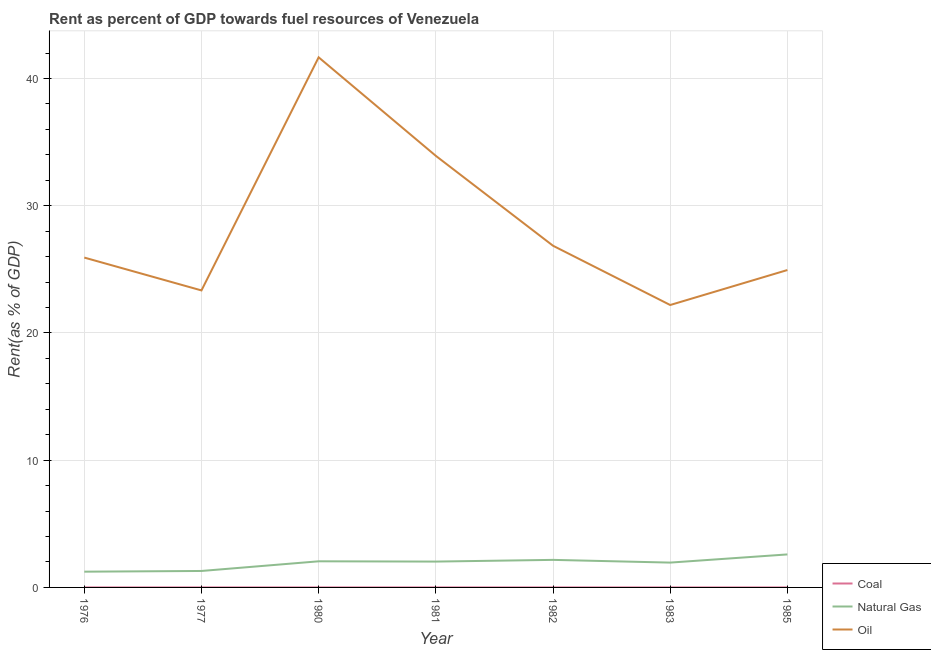Is the number of lines equal to the number of legend labels?
Your answer should be compact. Yes. What is the rent towards natural gas in 1981?
Your answer should be very brief. 2.03. Across all years, what is the maximum rent towards natural gas?
Offer a terse response. 2.59. Across all years, what is the minimum rent towards coal?
Provide a short and direct response. 0. What is the total rent towards natural gas in the graph?
Your answer should be very brief. 13.33. What is the difference between the rent towards oil in 1980 and that in 1982?
Your answer should be very brief. 14.81. What is the difference between the rent towards coal in 1977 and the rent towards natural gas in 1976?
Make the answer very short. -1.24. What is the average rent towards natural gas per year?
Offer a terse response. 1.9. In the year 1981, what is the difference between the rent towards coal and rent towards natural gas?
Offer a terse response. -2.03. What is the ratio of the rent towards oil in 1982 to that in 1985?
Your response must be concise. 1.08. What is the difference between the highest and the second highest rent towards coal?
Provide a short and direct response. 0. What is the difference between the highest and the lowest rent towards coal?
Make the answer very short. 0. Is it the case that in every year, the sum of the rent towards coal and rent towards natural gas is greater than the rent towards oil?
Your answer should be very brief. No. Does the rent towards natural gas monotonically increase over the years?
Offer a very short reply. No. Is the rent towards oil strictly greater than the rent towards natural gas over the years?
Keep it short and to the point. Yes. Is the rent towards coal strictly less than the rent towards oil over the years?
Offer a very short reply. Yes. How many lines are there?
Ensure brevity in your answer.  3. What is the difference between two consecutive major ticks on the Y-axis?
Provide a succinct answer. 10. Where does the legend appear in the graph?
Offer a terse response. Bottom right. How many legend labels are there?
Your response must be concise. 3. How are the legend labels stacked?
Make the answer very short. Vertical. What is the title of the graph?
Offer a terse response. Rent as percent of GDP towards fuel resources of Venezuela. Does "Social insurance" appear as one of the legend labels in the graph?
Offer a terse response. No. What is the label or title of the Y-axis?
Your answer should be very brief. Rent(as % of GDP). What is the Rent(as % of GDP) in Coal in 1976?
Ensure brevity in your answer.  0. What is the Rent(as % of GDP) of Natural Gas in 1976?
Make the answer very short. 1.24. What is the Rent(as % of GDP) of Oil in 1976?
Give a very brief answer. 25.92. What is the Rent(as % of GDP) of Coal in 1977?
Offer a very short reply. 0. What is the Rent(as % of GDP) in Natural Gas in 1977?
Your answer should be compact. 1.29. What is the Rent(as % of GDP) in Oil in 1977?
Your answer should be compact. 23.34. What is the Rent(as % of GDP) of Coal in 1980?
Offer a very short reply. 0. What is the Rent(as % of GDP) of Natural Gas in 1980?
Offer a very short reply. 2.05. What is the Rent(as % of GDP) in Oil in 1980?
Ensure brevity in your answer.  41.66. What is the Rent(as % of GDP) of Coal in 1981?
Provide a short and direct response. 0. What is the Rent(as % of GDP) of Natural Gas in 1981?
Your answer should be compact. 2.03. What is the Rent(as % of GDP) of Oil in 1981?
Make the answer very short. 33.92. What is the Rent(as % of GDP) of Coal in 1982?
Your answer should be very brief. 0. What is the Rent(as % of GDP) in Natural Gas in 1982?
Your answer should be compact. 2.17. What is the Rent(as % of GDP) in Oil in 1982?
Give a very brief answer. 26.85. What is the Rent(as % of GDP) of Coal in 1983?
Ensure brevity in your answer.  0. What is the Rent(as % of GDP) in Natural Gas in 1983?
Your answer should be very brief. 1.95. What is the Rent(as % of GDP) in Oil in 1983?
Keep it short and to the point. 22.2. What is the Rent(as % of GDP) in Coal in 1985?
Provide a succinct answer. 0. What is the Rent(as % of GDP) in Natural Gas in 1985?
Offer a very short reply. 2.59. What is the Rent(as % of GDP) of Oil in 1985?
Keep it short and to the point. 24.94. Across all years, what is the maximum Rent(as % of GDP) of Coal?
Your response must be concise. 0. Across all years, what is the maximum Rent(as % of GDP) in Natural Gas?
Your answer should be very brief. 2.59. Across all years, what is the maximum Rent(as % of GDP) in Oil?
Provide a short and direct response. 41.66. Across all years, what is the minimum Rent(as % of GDP) in Coal?
Give a very brief answer. 0. Across all years, what is the minimum Rent(as % of GDP) in Natural Gas?
Offer a very short reply. 1.24. Across all years, what is the minimum Rent(as % of GDP) of Oil?
Provide a short and direct response. 22.2. What is the total Rent(as % of GDP) of Coal in the graph?
Offer a very short reply. 0.01. What is the total Rent(as % of GDP) of Natural Gas in the graph?
Provide a succinct answer. 13.33. What is the total Rent(as % of GDP) of Oil in the graph?
Ensure brevity in your answer.  198.84. What is the difference between the Rent(as % of GDP) in Coal in 1976 and that in 1977?
Keep it short and to the point. -0. What is the difference between the Rent(as % of GDP) in Natural Gas in 1976 and that in 1977?
Your answer should be compact. -0.06. What is the difference between the Rent(as % of GDP) of Oil in 1976 and that in 1977?
Your response must be concise. 2.58. What is the difference between the Rent(as % of GDP) in Coal in 1976 and that in 1980?
Provide a short and direct response. 0. What is the difference between the Rent(as % of GDP) in Natural Gas in 1976 and that in 1980?
Your answer should be very brief. -0.82. What is the difference between the Rent(as % of GDP) in Oil in 1976 and that in 1980?
Provide a short and direct response. -15.74. What is the difference between the Rent(as % of GDP) of Coal in 1976 and that in 1981?
Your answer should be very brief. -0. What is the difference between the Rent(as % of GDP) in Natural Gas in 1976 and that in 1981?
Your answer should be very brief. -0.79. What is the difference between the Rent(as % of GDP) of Oil in 1976 and that in 1981?
Offer a very short reply. -7.99. What is the difference between the Rent(as % of GDP) of Coal in 1976 and that in 1982?
Give a very brief answer. -0. What is the difference between the Rent(as % of GDP) of Natural Gas in 1976 and that in 1982?
Your answer should be very brief. -0.93. What is the difference between the Rent(as % of GDP) in Oil in 1976 and that in 1982?
Your answer should be very brief. -0.93. What is the difference between the Rent(as % of GDP) in Coal in 1976 and that in 1983?
Offer a very short reply. 0. What is the difference between the Rent(as % of GDP) of Natural Gas in 1976 and that in 1983?
Provide a succinct answer. -0.71. What is the difference between the Rent(as % of GDP) in Oil in 1976 and that in 1983?
Provide a succinct answer. 3.73. What is the difference between the Rent(as % of GDP) in Coal in 1976 and that in 1985?
Provide a short and direct response. 0. What is the difference between the Rent(as % of GDP) in Natural Gas in 1976 and that in 1985?
Your answer should be compact. -1.36. What is the difference between the Rent(as % of GDP) of Oil in 1976 and that in 1985?
Your answer should be compact. 0.98. What is the difference between the Rent(as % of GDP) of Coal in 1977 and that in 1980?
Provide a short and direct response. 0. What is the difference between the Rent(as % of GDP) of Natural Gas in 1977 and that in 1980?
Make the answer very short. -0.76. What is the difference between the Rent(as % of GDP) of Oil in 1977 and that in 1980?
Offer a terse response. -18.32. What is the difference between the Rent(as % of GDP) in Coal in 1977 and that in 1981?
Provide a short and direct response. -0. What is the difference between the Rent(as % of GDP) in Natural Gas in 1977 and that in 1981?
Give a very brief answer. -0.74. What is the difference between the Rent(as % of GDP) of Oil in 1977 and that in 1981?
Provide a succinct answer. -10.58. What is the difference between the Rent(as % of GDP) in Coal in 1977 and that in 1982?
Offer a very short reply. -0. What is the difference between the Rent(as % of GDP) in Natural Gas in 1977 and that in 1982?
Ensure brevity in your answer.  -0.87. What is the difference between the Rent(as % of GDP) of Oil in 1977 and that in 1982?
Your response must be concise. -3.51. What is the difference between the Rent(as % of GDP) in Coal in 1977 and that in 1983?
Provide a succinct answer. 0. What is the difference between the Rent(as % of GDP) in Natural Gas in 1977 and that in 1983?
Keep it short and to the point. -0.66. What is the difference between the Rent(as % of GDP) in Oil in 1977 and that in 1983?
Make the answer very short. 1.15. What is the difference between the Rent(as % of GDP) in Coal in 1977 and that in 1985?
Keep it short and to the point. 0. What is the difference between the Rent(as % of GDP) of Natural Gas in 1977 and that in 1985?
Provide a succinct answer. -1.3. What is the difference between the Rent(as % of GDP) in Oil in 1977 and that in 1985?
Make the answer very short. -1.6. What is the difference between the Rent(as % of GDP) in Coal in 1980 and that in 1981?
Provide a short and direct response. -0. What is the difference between the Rent(as % of GDP) of Natural Gas in 1980 and that in 1981?
Offer a very short reply. 0.02. What is the difference between the Rent(as % of GDP) of Oil in 1980 and that in 1981?
Make the answer very short. 7.74. What is the difference between the Rent(as % of GDP) of Coal in 1980 and that in 1982?
Keep it short and to the point. -0. What is the difference between the Rent(as % of GDP) of Natural Gas in 1980 and that in 1982?
Your answer should be compact. -0.11. What is the difference between the Rent(as % of GDP) in Oil in 1980 and that in 1982?
Provide a succinct answer. 14.81. What is the difference between the Rent(as % of GDP) in Natural Gas in 1980 and that in 1983?
Your answer should be very brief. 0.1. What is the difference between the Rent(as % of GDP) in Oil in 1980 and that in 1983?
Provide a short and direct response. 19.47. What is the difference between the Rent(as % of GDP) in Coal in 1980 and that in 1985?
Keep it short and to the point. 0. What is the difference between the Rent(as % of GDP) of Natural Gas in 1980 and that in 1985?
Offer a terse response. -0.54. What is the difference between the Rent(as % of GDP) in Oil in 1980 and that in 1985?
Provide a short and direct response. 16.72. What is the difference between the Rent(as % of GDP) of Coal in 1981 and that in 1982?
Offer a terse response. -0. What is the difference between the Rent(as % of GDP) of Natural Gas in 1981 and that in 1982?
Your response must be concise. -0.13. What is the difference between the Rent(as % of GDP) in Oil in 1981 and that in 1982?
Provide a succinct answer. 7.06. What is the difference between the Rent(as % of GDP) in Coal in 1981 and that in 1983?
Your answer should be very brief. 0. What is the difference between the Rent(as % of GDP) in Oil in 1981 and that in 1983?
Offer a terse response. 11.72. What is the difference between the Rent(as % of GDP) in Coal in 1981 and that in 1985?
Give a very brief answer. 0. What is the difference between the Rent(as % of GDP) of Natural Gas in 1981 and that in 1985?
Ensure brevity in your answer.  -0.56. What is the difference between the Rent(as % of GDP) in Oil in 1981 and that in 1985?
Give a very brief answer. 8.97. What is the difference between the Rent(as % of GDP) in Coal in 1982 and that in 1983?
Offer a very short reply. 0. What is the difference between the Rent(as % of GDP) of Natural Gas in 1982 and that in 1983?
Offer a terse response. 0.21. What is the difference between the Rent(as % of GDP) of Oil in 1982 and that in 1983?
Offer a very short reply. 4.66. What is the difference between the Rent(as % of GDP) of Coal in 1982 and that in 1985?
Provide a short and direct response. 0. What is the difference between the Rent(as % of GDP) in Natural Gas in 1982 and that in 1985?
Give a very brief answer. -0.43. What is the difference between the Rent(as % of GDP) of Oil in 1982 and that in 1985?
Ensure brevity in your answer.  1.91. What is the difference between the Rent(as % of GDP) of Natural Gas in 1983 and that in 1985?
Your answer should be compact. -0.64. What is the difference between the Rent(as % of GDP) of Oil in 1983 and that in 1985?
Offer a terse response. -2.75. What is the difference between the Rent(as % of GDP) in Coal in 1976 and the Rent(as % of GDP) in Natural Gas in 1977?
Ensure brevity in your answer.  -1.29. What is the difference between the Rent(as % of GDP) of Coal in 1976 and the Rent(as % of GDP) of Oil in 1977?
Your answer should be compact. -23.34. What is the difference between the Rent(as % of GDP) in Natural Gas in 1976 and the Rent(as % of GDP) in Oil in 1977?
Your answer should be compact. -22.1. What is the difference between the Rent(as % of GDP) in Coal in 1976 and the Rent(as % of GDP) in Natural Gas in 1980?
Your answer should be very brief. -2.05. What is the difference between the Rent(as % of GDP) in Coal in 1976 and the Rent(as % of GDP) in Oil in 1980?
Your response must be concise. -41.66. What is the difference between the Rent(as % of GDP) of Natural Gas in 1976 and the Rent(as % of GDP) of Oil in 1980?
Give a very brief answer. -40.42. What is the difference between the Rent(as % of GDP) in Coal in 1976 and the Rent(as % of GDP) in Natural Gas in 1981?
Your answer should be compact. -2.03. What is the difference between the Rent(as % of GDP) in Coal in 1976 and the Rent(as % of GDP) in Oil in 1981?
Give a very brief answer. -33.92. What is the difference between the Rent(as % of GDP) in Natural Gas in 1976 and the Rent(as % of GDP) in Oil in 1981?
Offer a very short reply. -32.68. What is the difference between the Rent(as % of GDP) of Coal in 1976 and the Rent(as % of GDP) of Natural Gas in 1982?
Provide a succinct answer. -2.16. What is the difference between the Rent(as % of GDP) of Coal in 1976 and the Rent(as % of GDP) of Oil in 1982?
Your answer should be compact. -26.85. What is the difference between the Rent(as % of GDP) of Natural Gas in 1976 and the Rent(as % of GDP) of Oil in 1982?
Ensure brevity in your answer.  -25.62. What is the difference between the Rent(as % of GDP) of Coal in 1976 and the Rent(as % of GDP) of Natural Gas in 1983?
Make the answer very short. -1.95. What is the difference between the Rent(as % of GDP) in Coal in 1976 and the Rent(as % of GDP) in Oil in 1983?
Offer a very short reply. -22.19. What is the difference between the Rent(as % of GDP) of Natural Gas in 1976 and the Rent(as % of GDP) of Oil in 1983?
Your answer should be compact. -20.96. What is the difference between the Rent(as % of GDP) in Coal in 1976 and the Rent(as % of GDP) in Natural Gas in 1985?
Offer a very short reply. -2.59. What is the difference between the Rent(as % of GDP) of Coal in 1976 and the Rent(as % of GDP) of Oil in 1985?
Provide a succinct answer. -24.94. What is the difference between the Rent(as % of GDP) of Natural Gas in 1976 and the Rent(as % of GDP) of Oil in 1985?
Ensure brevity in your answer.  -23.71. What is the difference between the Rent(as % of GDP) in Coal in 1977 and the Rent(as % of GDP) in Natural Gas in 1980?
Make the answer very short. -2.05. What is the difference between the Rent(as % of GDP) of Coal in 1977 and the Rent(as % of GDP) of Oil in 1980?
Your answer should be very brief. -41.66. What is the difference between the Rent(as % of GDP) in Natural Gas in 1977 and the Rent(as % of GDP) in Oil in 1980?
Give a very brief answer. -40.37. What is the difference between the Rent(as % of GDP) in Coal in 1977 and the Rent(as % of GDP) in Natural Gas in 1981?
Your answer should be very brief. -2.03. What is the difference between the Rent(as % of GDP) of Coal in 1977 and the Rent(as % of GDP) of Oil in 1981?
Your answer should be very brief. -33.92. What is the difference between the Rent(as % of GDP) in Natural Gas in 1977 and the Rent(as % of GDP) in Oil in 1981?
Offer a very short reply. -32.62. What is the difference between the Rent(as % of GDP) in Coal in 1977 and the Rent(as % of GDP) in Natural Gas in 1982?
Your answer should be compact. -2.16. What is the difference between the Rent(as % of GDP) of Coal in 1977 and the Rent(as % of GDP) of Oil in 1982?
Offer a terse response. -26.85. What is the difference between the Rent(as % of GDP) of Natural Gas in 1977 and the Rent(as % of GDP) of Oil in 1982?
Provide a short and direct response. -25.56. What is the difference between the Rent(as % of GDP) of Coal in 1977 and the Rent(as % of GDP) of Natural Gas in 1983?
Your response must be concise. -1.95. What is the difference between the Rent(as % of GDP) of Coal in 1977 and the Rent(as % of GDP) of Oil in 1983?
Your answer should be compact. -22.19. What is the difference between the Rent(as % of GDP) in Natural Gas in 1977 and the Rent(as % of GDP) in Oil in 1983?
Give a very brief answer. -20.9. What is the difference between the Rent(as % of GDP) of Coal in 1977 and the Rent(as % of GDP) of Natural Gas in 1985?
Ensure brevity in your answer.  -2.59. What is the difference between the Rent(as % of GDP) in Coal in 1977 and the Rent(as % of GDP) in Oil in 1985?
Your response must be concise. -24.94. What is the difference between the Rent(as % of GDP) in Natural Gas in 1977 and the Rent(as % of GDP) in Oil in 1985?
Provide a succinct answer. -23.65. What is the difference between the Rent(as % of GDP) in Coal in 1980 and the Rent(as % of GDP) in Natural Gas in 1981?
Offer a terse response. -2.03. What is the difference between the Rent(as % of GDP) in Coal in 1980 and the Rent(as % of GDP) in Oil in 1981?
Your response must be concise. -33.92. What is the difference between the Rent(as % of GDP) of Natural Gas in 1980 and the Rent(as % of GDP) of Oil in 1981?
Provide a short and direct response. -31.86. What is the difference between the Rent(as % of GDP) in Coal in 1980 and the Rent(as % of GDP) in Natural Gas in 1982?
Provide a succinct answer. -2.17. What is the difference between the Rent(as % of GDP) of Coal in 1980 and the Rent(as % of GDP) of Oil in 1982?
Offer a terse response. -26.85. What is the difference between the Rent(as % of GDP) of Natural Gas in 1980 and the Rent(as % of GDP) of Oil in 1982?
Give a very brief answer. -24.8. What is the difference between the Rent(as % of GDP) of Coal in 1980 and the Rent(as % of GDP) of Natural Gas in 1983?
Ensure brevity in your answer.  -1.95. What is the difference between the Rent(as % of GDP) in Coal in 1980 and the Rent(as % of GDP) in Oil in 1983?
Your answer should be very brief. -22.2. What is the difference between the Rent(as % of GDP) in Natural Gas in 1980 and the Rent(as % of GDP) in Oil in 1983?
Your answer should be very brief. -20.14. What is the difference between the Rent(as % of GDP) in Coal in 1980 and the Rent(as % of GDP) in Natural Gas in 1985?
Keep it short and to the point. -2.59. What is the difference between the Rent(as % of GDP) of Coal in 1980 and the Rent(as % of GDP) of Oil in 1985?
Ensure brevity in your answer.  -24.94. What is the difference between the Rent(as % of GDP) in Natural Gas in 1980 and the Rent(as % of GDP) in Oil in 1985?
Ensure brevity in your answer.  -22.89. What is the difference between the Rent(as % of GDP) in Coal in 1981 and the Rent(as % of GDP) in Natural Gas in 1982?
Your answer should be very brief. -2.16. What is the difference between the Rent(as % of GDP) in Coal in 1981 and the Rent(as % of GDP) in Oil in 1982?
Provide a short and direct response. -26.85. What is the difference between the Rent(as % of GDP) of Natural Gas in 1981 and the Rent(as % of GDP) of Oil in 1982?
Your answer should be compact. -24.82. What is the difference between the Rent(as % of GDP) of Coal in 1981 and the Rent(as % of GDP) of Natural Gas in 1983?
Give a very brief answer. -1.95. What is the difference between the Rent(as % of GDP) of Coal in 1981 and the Rent(as % of GDP) of Oil in 1983?
Make the answer very short. -22.19. What is the difference between the Rent(as % of GDP) in Natural Gas in 1981 and the Rent(as % of GDP) in Oil in 1983?
Provide a succinct answer. -20.16. What is the difference between the Rent(as % of GDP) of Coal in 1981 and the Rent(as % of GDP) of Natural Gas in 1985?
Offer a very short reply. -2.59. What is the difference between the Rent(as % of GDP) of Coal in 1981 and the Rent(as % of GDP) of Oil in 1985?
Provide a short and direct response. -24.94. What is the difference between the Rent(as % of GDP) of Natural Gas in 1981 and the Rent(as % of GDP) of Oil in 1985?
Your answer should be compact. -22.91. What is the difference between the Rent(as % of GDP) of Coal in 1982 and the Rent(as % of GDP) of Natural Gas in 1983?
Keep it short and to the point. -1.95. What is the difference between the Rent(as % of GDP) of Coal in 1982 and the Rent(as % of GDP) of Oil in 1983?
Your answer should be compact. -22.19. What is the difference between the Rent(as % of GDP) in Natural Gas in 1982 and the Rent(as % of GDP) in Oil in 1983?
Your answer should be compact. -20.03. What is the difference between the Rent(as % of GDP) of Coal in 1982 and the Rent(as % of GDP) of Natural Gas in 1985?
Make the answer very short. -2.59. What is the difference between the Rent(as % of GDP) of Coal in 1982 and the Rent(as % of GDP) of Oil in 1985?
Make the answer very short. -24.94. What is the difference between the Rent(as % of GDP) in Natural Gas in 1982 and the Rent(as % of GDP) in Oil in 1985?
Give a very brief answer. -22.78. What is the difference between the Rent(as % of GDP) in Coal in 1983 and the Rent(as % of GDP) in Natural Gas in 1985?
Ensure brevity in your answer.  -2.59. What is the difference between the Rent(as % of GDP) of Coal in 1983 and the Rent(as % of GDP) of Oil in 1985?
Provide a succinct answer. -24.94. What is the difference between the Rent(as % of GDP) of Natural Gas in 1983 and the Rent(as % of GDP) of Oil in 1985?
Keep it short and to the point. -22.99. What is the average Rent(as % of GDP) of Coal per year?
Provide a succinct answer. 0. What is the average Rent(as % of GDP) in Natural Gas per year?
Your answer should be compact. 1.9. What is the average Rent(as % of GDP) in Oil per year?
Your response must be concise. 28.41. In the year 1976, what is the difference between the Rent(as % of GDP) of Coal and Rent(as % of GDP) of Natural Gas?
Your response must be concise. -1.24. In the year 1976, what is the difference between the Rent(as % of GDP) of Coal and Rent(as % of GDP) of Oil?
Ensure brevity in your answer.  -25.92. In the year 1976, what is the difference between the Rent(as % of GDP) in Natural Gas and Rent(as % of GDP) in Oil?
Your answer should be very brief. -24.69. In the year 1977, what is the difference between the Rent(as % of GDP) in Coal and Rent(as % of GDP) in Natural Gas?
Your response must be concise. -1.29. In the year 1977, what is the difference between the Rent(as % of GDP) in Coal and Rent(as % of GDP) in Oil?
Your answer should be compact. -23.34. In the year 1977, what is the difference between the Rent(as % of GDP) of Natural Gas and Rent(as % of GDP) of Oil?
Your answer should be compact. -22.05. In the year 1980, what is the difference between the Rent(as % of GDP) in Coal and Rent(as % of GDP) in Natural Gas?
Ensure brevity in your answer.  -2.05. In the year 1980, what is the difference between the Rent(as % of GDP) of Coal and Rent(as % of GDP) of Oil?
Your answer should be very brief. -41.66. In the year 1980, what is the difference between the Rent(as % of GDP) of Natural Gas and Rent(as % of GDP) of Oil?
Ensure brevity in your answer.  -39.61. In the year 1981, what is the difference between the Rent(as % of GDP) of Coal and Rent(as % of GDP) of Natural Gas?
Your response must be concise. -2.03. In the year 1981, what is the difference between the Rent(as % of GDP) in Coal and Rent(as % of GDP) in Oil?
Your answer should be compact. -33.92. In the year 1981, what is the difference between the Rent(as % of GDP) in Natural Gas and Rent(as % of GDP) in Oil?
Provide a succinct answer. -31.89. In the year 1982, what is the difference between the Rent(as % of GDP) in Coal and Rent(as % of GDP) in Natural Gas?
Provide a short and direct response. -2.16. In the year 1982, what is the difference between the Rent(as % of GDP) of Coal and Rent(as % of GDP) of Oil?
Keep it short and to the point. -26.85. In the year 1982, what is the difference between the Rent(as % of GDP) of Natural Gas and Rent(as % of GDP) of Oil?
Keep it short and to the point. -24.69. In the year 1983, what is the difference between the Rent(as % of GDP) of Coal and Rent(as % of GDP) of Natural Gas?
Offer a very short reply. -1.95. In the year 1983, what is the difference between the Rent(as % of GDP) in Coal and Rent(as % of GDP) in Oil?
Your response must be concise. -22.2. In the year 1983, what is the difference between the Rent(as % of GDP) in Natural Gas and Rent(as % of GDP) in Oil?
Make the answer very short. -20.24. In the year 1985, what is the difference between the Rent(as % of GDP) of Coal and Rent(as % of GDP) of Natural Gas?
Offer a terse response. -2.59. In the year 1985, what is the difference between the Rent(as % of GDP) in Coal and Rent(as % of GDP) in Oil?
Ensure brevity in your answer.  -24.94. In the year 1985, what is the difference between the Rent(as % of GDP) of Natural Gas and Rent(as % of GDP) of Oil?
Offer a terse response. -22.35. What is the ratio of the Rent(as % of GDP) of Coal in 1976 to that in 1977?
Your answer should be very brief. 0.94. What is the ratio of the Rent(as % of GDP) of Natural Gas in 1976 to that in 1977?
Ensure brevity in your answer.  0.96. What is the ratio of the Rent(as % of GDP) in Oil in 1976 to that in 1977?
Provide a short and direct response. 1.11. What is the ratio of the Rent(as % of GDP) of Coal in 1976 to that in 1980?
Your response must be concise. 3.46. What is the ratio of the Rent(as % of GDP) of Natural Gas in 1976 to that in 1980?
Give a very brief answer. 0.6. What is the ratio of the Rent(as % of GDP) of Oil in 1976 to that in 1980?
Your answer should be compact. 0.62. What is the ratio of the Rent(as % of GDP) in Coal in 1976 to that in 1981?
Give a very brief answer. 0.75. What is the ratio of the Rent(as % of GDP) in Natural Gas in 1976 to that in 1981?
Make the answer very short. 0.61. What is the ratio of the Rent(as % of GDP) of Oil in 1976 to that in 1981?
Make the answer very short. 0.76. What is the ratio of the Rent(as % of GDP) of Coal in 1976 to that in 1982?
Your answer should be very brief. 0.65. What is the ratio of the Rent(as % of GDP) in Natural Gas in 1976 to that in 1982?
Ensure brevity in your answer.  0.57. What is the ratio of the Rent(as % of GDP) in Oil in 1976 to that in 1982?
Give a very brief answer. 0.97. What is the ratio of the Rent(as % of GDP) of Coal in 1976 to that in 1983?
Ensure brevity in your answer.  4.58. What is the ratio of the Rent(as % of GDP) of Natural Gas in 1976 to that in 1983?
Provide a short and direct response. 0.63. What is the ratio of the Rent(as % of GDP) of Oil in 1976 to that in 1983?
Provide a succinct answer. 1.17. What is the ratio of the Rent(as % of GDP) of Coal in 1976 to that in 1985?
Your answer should be compact. 6.37. What is the ratio of the Rent(as % of GDP) in Natural Gas in 1976 to that in 1985?
Provide a short and direct response. 0.48. What is the ratio of the Rent(as % of GDP) in Oil in 1976 to that in 1985?
Your response must be concise. 1.04. What is the ratio of the Rent(as % of GDP) in Coal in 1977 to that in 1980?
Provide a short and direct response. 3.7. What is the ratio of the Rent(as % of GDP) in Natural Gas in 1977 to that in 1980?
Give a very brief answer. 0.63. What is the ratio of the Rent(as % of GDP) in Oil in 1977 to that in 1980?
Offer a very short reply. 0.56. What is the ratio of the Rent(as % of GDP) of Coal in 1977 to that in 1981?
Ensure brevity in your answer.  0.8. What is the ratio of the Rent(as % of GDP) of Natural Gas in 1977 to that in 1981?
Make the answer very short. 0.64. What is the ratio of the Rent(as % of GDP) of Oil in 1977 to that in 1981?
Provide a short and direct response. 0.69. What is the ratio of the Rent(as % of GDP) in Coal in 1977 to that in 1982?
Keep it short and to the point. 0.69. What is the ratio of the Rent(as % of GDP) of Natural Gas in 1977 to that in 1982?
Provide a succinct answer. 0.6. What is the ratio of the Rent(as % of GDP) in Oil in 1977 to that in 1982?
Offer a terse response. 0.87. What is the ratio of the Rent(as % of GDP) in Coal in 1977 to that in 1983?
Offer a very short reply. 4.89. What is the ratio of the Rent(as % of GDP) in Natural Gas in 1977 to that in 1983?
Give a very brief answer. 0.66. What is the ratio of the Rent(as % of GDP) of Oil in 1977 to that in 1983?
Provide a short and direct response. 1.05. What is the ratio of the Rent(as % of GDP) in Coal in 1977 to that in 1985?
Offer a terse response. 6.79. What is the ratio of the Rent(as % of GDP) in Natural Gas in 1977 to that in 1985?
Provide a succinct answer. 0.5. What is the ratio of the Rent(as % of GDP) of Oil in 1977 to that in 1985?
Your answer should be compact. 0.94. What is the ratio of the Rent(as % of GDP) of Coal in 1980 to that in 1981?
Keep it short and to the point. 0.22. What is the ratio of the Rent(as % of GDP) in Natural Gas in 1980 to that in 1981?
Offer a very short reply. 1.01. What is the ratio of the Rent(as % of GDP) of Oil in 1980 to that in 1981?
Your answer should be compact. 1.23. What is the ratio of the Rent(as % of GDP) of Coal in 1980 to that in 1982?
Provide a succinct answer. 0.19. What is the ratio of the Rent(as % of GDP) in Natural Gas in 1980 to that in 1982?
Ensure brevity in your answer.  0.95. What is the ratio of the Rent(as % of GDP) in Oil in 1980 to that in 1982?
Give a very brief answer. 1.55. What is the ratio of the Rent(as % of GDP) of Coal in 1980 to that in 1983?
Keep it short and to the point. 1.32. What is the ratio of the Rent(as % of GDP) of Natural Gas in 1980 to that in 1983?
Offer a very short reply. 1.05. What is the ratio of the Rent(as % of GDP) in Oil in 1980 to that in 1983?
Offer a very short reply. 1.88. What is the ratio of the Rent(as % of GDP) in Coal in 1980 to that in 1985?
Offer a very short reply. 1.84. What is the ratio of the Rent(as % of GDP) in Natural Gas in 1980 to that in 1985?
Offer a very short reply. 0.79. What is the ratio of the Rent(as % of GDP) of Oil in 1980 to that in 1985?
Offer a terse response. 1.67. What is the ratio of the Rent(as % of GDP) in Coal in 1981 to that in 1982?
Ensure brevity in your answer.  0.86. What is the ratio of the Rent(as % of GDP) in Natural Gas in 1981 to that in 1982?
Offer a terse response. 0.94. What is the ratio of the Rent(as % of GDP) of Oil in 1981 to that in 1982?
Your answer should be compact. 1.26. What is the ratio of the Rent(as % of GDP) in Coal in 1981 to that in 1983?
Offer a terse response. 6.11. What is the ratio of the Rent(as % of GDP) of Natural Gas in 1981 to that in 1983?
Give a very brief answer. 1.04. What is the ratio of the Rent(as % of GDP) in Oil in 1981 to that in 1983?
Offer a very short reply. 1.53. What is the ratio of the Rent(as % of GDP) in Coal in 1981 to that in 1985?
Your response must be concise. 8.49. What is the ratio of the Rent(as % of GDP) in Natural Gas in 1981 to that in 1985?
Offer a very short reply. 0.78. What is the ratio of the Rent(as % of GDP) of Oil in 1981 to that in 1985?
Make the answer very short. 1.36. What is the ratio of the Rent(as % of GDP) in Coal in 1982 to that in 1983?
Ensure brevity in your answer.  7.06. What is the ratio of the Rent(as % of GDP) of Natural Gas in 1982 to that in 1983?
Keep it short and to the point. 1.11. What is the ratio of the Rent(as % of GDP) in Oil in 1982 to that in 1983?
Provide a short and direct response. 1.21. What is the ratio of the Rent(as % of GDP) in Coal in 1982 to that in 1985?
Give a very brief answer. 9.81. What is the ratio of the Rent(as % of GDP) of Natural Gas in 1982 to that in 1985?
Your answer should be very brief. 0.83. What is the ratio of the Rent(as % of GDP) of Oil in 1982 to that in 1985?
Give a very brief answer. 1.08. What is the ratio of the Rent(as % of GDP) in Coal in 1983 to that in 1985?
Provide a succinct answer. 1.39. What is the ratio of the Rent(as % of GDP) in Natural Gas in 1983 to that in 1985?
Offer a very short reply. 0.75. What is the ratio of the Rent(as % of GDP) of Oil in 1983 to that in 1985?
Provide a short and direct response. 0.89. What is the difference between the highest and the second highest Rent(as % of GDP) of Coal?
Your answer should be very brief. 0. What is the difference between the highest and the second highest Rent(as % of GDP) of Natural Gas?
Keep it short and to the point. 0.43. What is the difference between the highest and the second highest Rent(as % of GDP) of Oil?
Ensure brevity in your answer.  7.74. What is the difference between the highest and the lowest Rent(as % of GDP) in Coal?
Provide a succinct answer. 0. What is the difference between the highest and the lowest Rent(as % of GDP) in Natural Gas?
Offer a terse response. 1.36. What is the difference between the highest and the lowest Rent(as % of GDP) in Oil?
Provide a short and direct response. 19.47. 